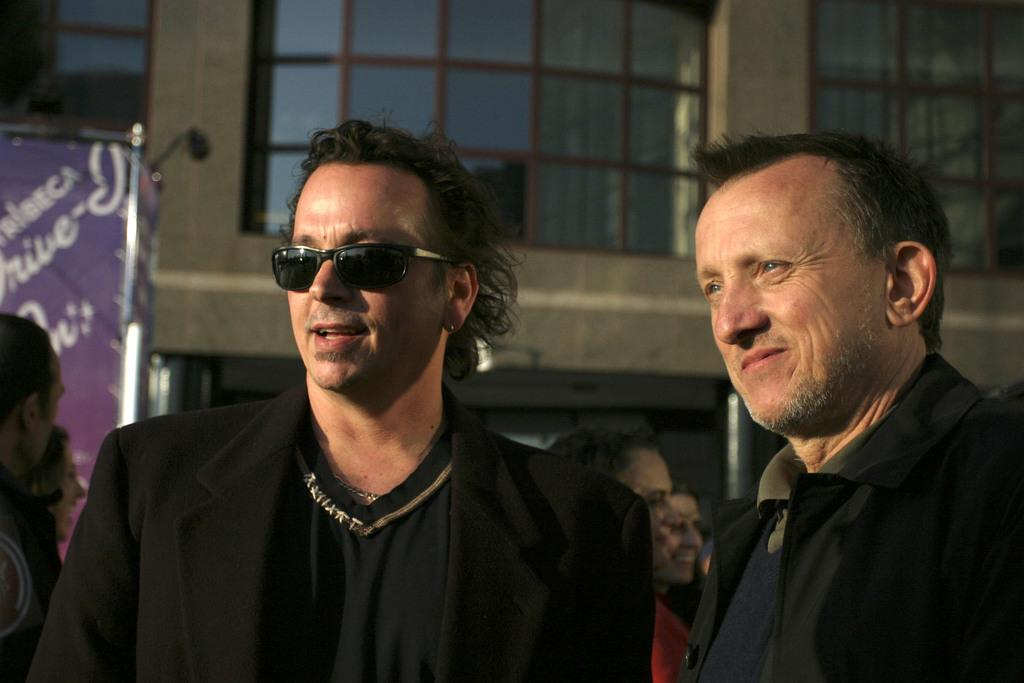What is happening in the image? There are people standing in the image. What can be seen in the distance behind the people? There are buildings in the background of the image. Is there anything else visible in the background? Yes, there is an advertisement in the background of the image. What type of instrument is being played in the church in the image? There is no church or instrument present in the image. 